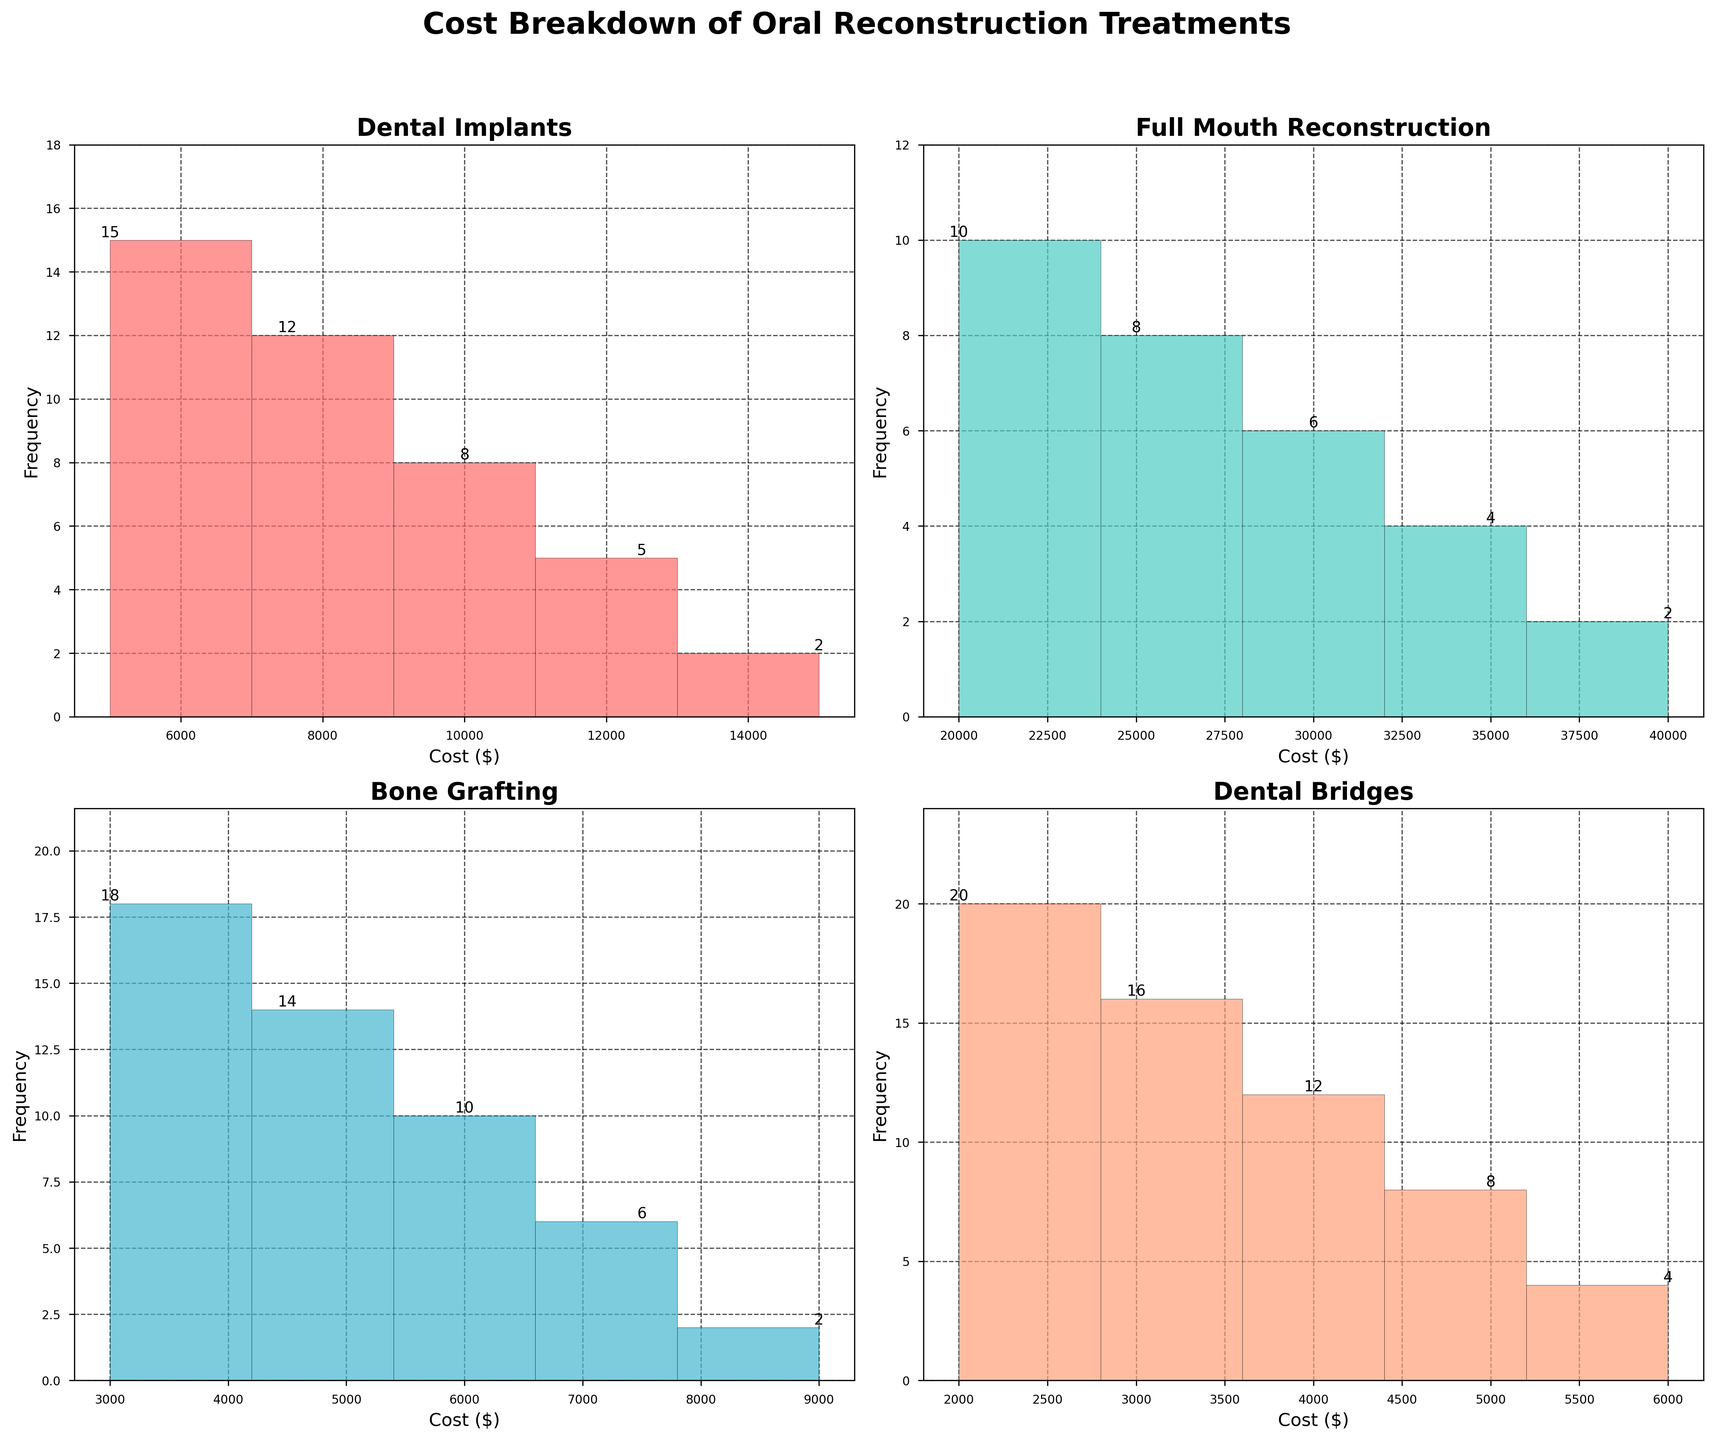How many treatments are there in total? The figure shows four subplots, each representing a different treatment. Therefore, the total number of treatments shown in the figure is four.
Answer: 4 What's the highest cost category for Dental Implants? The highest cost category displayed on the histogram for Dental Implants is $15,000. This is the rightmost bar in that subplot.
Answer: $15,000 Which treatment has the highest frequency at the lowest cost category? Look at the lowest cost category in each histogram and compare the frequencies. The lowest cost category for Dental Bridges shows a frequency of 20, which is the highest compared to other treatments’ lowest cost categories.
Answer: Dental Bridges Compare the frequency of the $6,000 cost category between Bone Grafting and Dental Bridges. Which is higher? The $6,000 cost category for Bone Grafting has a frequency of 2, whereas for Dental Bridges, it has a frequency of 4. Therefore, Dental Bridges has a higher frequency in the $6,000 cost category.
Answer: Dental Bridges What is the total frequency for the cost categories of Full Mouth Reconstruction? Add the frequencies of all cost categories for Full Mouth Reconstruction: 10 + 8 + 6 + 4 + 2. The sum is 30.
Answer: 30 Which treatment has its highest frequency at the $3,000 cost category? The $3,000 cost category in the histogram for Bone Grafting shows a frequency of 18, which is the highest frequency for that treatment.
Answer: Bone Grafting What is the combined frequency of the $5,000 and $10,000 cost categories for Dental Implants? Add the frequencies of the $5,000 and $10,000 cost categories for Dental Implants: 15 + 8. The sum is 23.
Answer: 23 Compare the total frequency for Bone Grafting and Dental Implants. Which one is higher? Total frequency for Bone Grafting is 18 + 14 + 10 + 6 + 2 = 50. Total frequency for Dental Implants is 15 + 12 + 8 + 5 + 2 = 42. Bone Grafting has a higher total frequency.
Answer: Bone Grafting What is the median cost category for Full Mouth Reconstruction? The cost categories are $20,000, $25,000, $30,000, $35,000, and $40,000. Arranged in ascending order, the median (middle value) is $30,000.
Answer: $30,000 